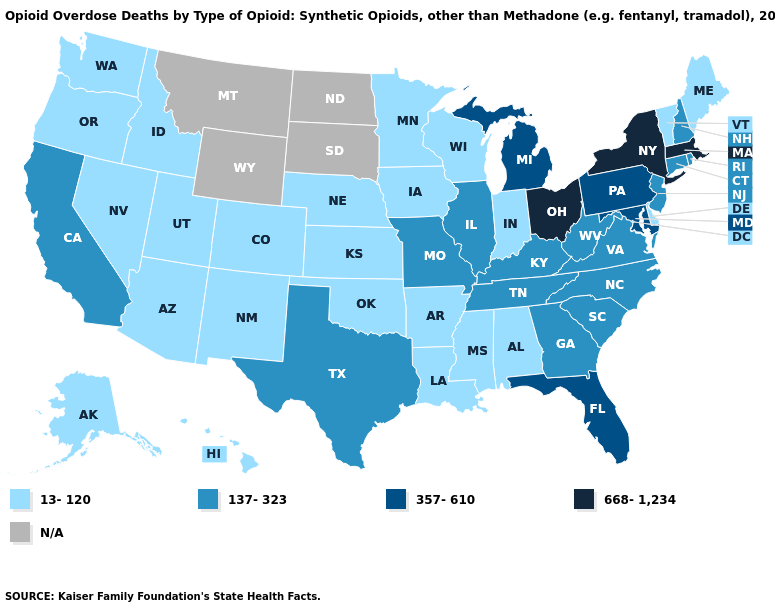Name the states that have a value in the range N/A?
Be succinct. Montana, North Dakota, South Dakota, Wyoming. Among the states that border Ohio , does Indiana have the lowest value?
Give a very brief answer. Yes. Does the map have missing data?
Keep it brief. Yes. Which states have the lowest value in the USA?
Write a very short answer. Alabama, Alaska, Arizona, Arkansas, Colorado, Delaware, Hawaii, Idaho, Indiana, Iowa, Kansas, Louisiana, Maine, Minnesota, Mississippi, Nebraska, Nevada, New Mexico, Oklahoma, Oregon, Utah, Vermont, Washington, Wisconsin. Name the states that have a value in the range 357-610?
Short answer required. Florida, Maryland, Michigan, Pennsylvania. Which states have the lowest value in the USA?
Answer briefly. Alabama, Alaska, Arizona, Arkansas, Colorado, Delaware, Hawaii, Idaho, Indiana, Iowa, Kansas, Louisiana, Maine, Minnesota, Mississippi, Nebraska, Nevada, New Mexico, Oklahoma, Oregon, Utah, Vermont, Washington, Wisconsin. What is the highest value in states that border Tennessee?
Concise answer only. 137-323. How many symbols are there in the legend?
Concise answer only. 5. Name the states that have a value in the range 668-1,234?
Short answer required. Massachusetts, New York, Ohio. What is the value of Missouri?
Give a very brief answer. 137-323. Among the states that border Indiana , which have the lowest value?
Answer briefly. Illinois, Kentucky. Name the states that have a value in the range 137-323?
Quick response, please. California, Connecticut, Georgia, Illinois, Kentucky, Missouri, New Hampshire, New Jersey, North Carolina, Rhode Island, South Carolina, Tennessee, Texas, Virginia, West Virginia. Which states have the lowest value in the South?
Short answer required. Alabama, Arkansas, Delaware, Louisiana, Mississippi, Oklahoma. What is the value of Colorado?
Be succinct. 13-120. What is the highest value in the USA?
Concise answer only. 668-1,234. 